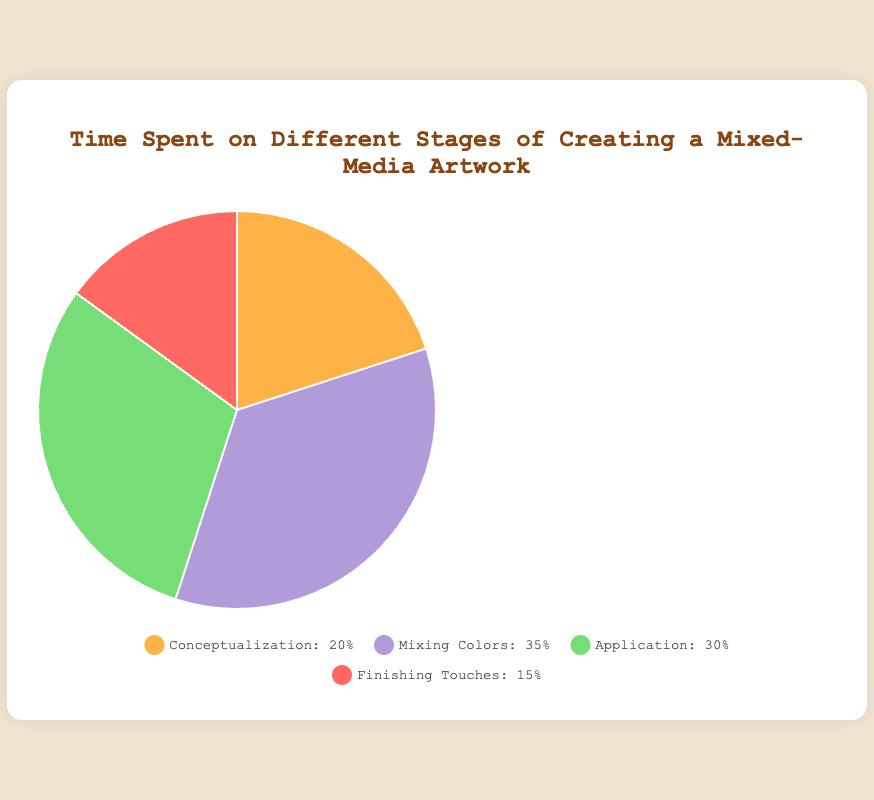What percentage of time is spent on Mixing Colors? The figure shows a pie chart that visually represents the time distribution. From the chart, "Mixing Colors" is labeled with a percentage value.
Answer: 35% Which stage has the least amount of time spent? By visually inspecting the pie chart, we can see that the section labeled "Finishing Touches" takes up the smallest portion of the chart.
Answer: Finishing Touches What is the total percentage of time spent on Conceptualization and Application combined? Add the percentages for both stages: Conceptualization (20%) and Application (30%). 20% + 30% = 50%.
Answer: 50% How much more time is spent on Mixing Colors compared to Finishing Touches? Subtract the percentage for Finishing Touches (15%) from that for Mixing Colors (35%). 35% - 15% = 20%.
Answer: 20% Order the stages from most time-consuming to least time-consuming. By ranking the percentages from the pie chart: Mixing Colors (35%), Application (30%), Conceptualization (20%), Finishing Touches (15%).
Answer: Mixing Colors, Application, Conceptualization, Finishing Touches What percentage of time is devoted to the stages other than Mixing Colors? Sum the percentages of stages other than Mixing Colors: Conceptualization (20%), Application (30%), Finishing Touches (15%). 20% + 30% + 15% = 65%.
Answer: 65% Which stage involves experimenting and creating unique pigments? According to the description provided, the stage "Mixing Colors" involves experimenting with and creating unique pigments.
Answer: Mixing Colors 